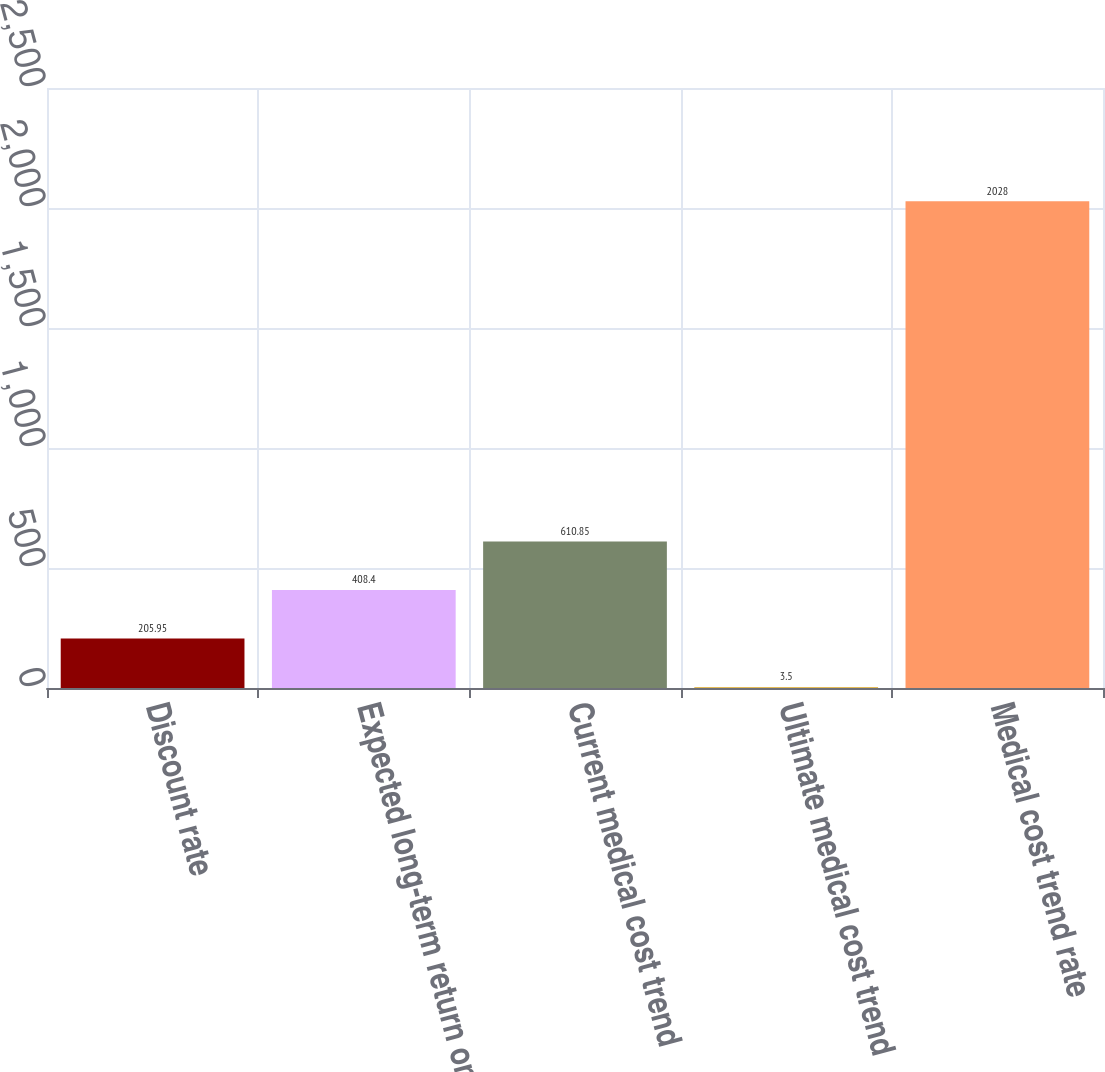<chart> <loc_0><loc_0><loc_500><loc_500><bar_chart><fcel>Discount rate<fcel>Expected long-term return on<fcel>Current medical cost trend<fcel>Ultimate medical cost trend<fcel>Medical cost trend rate<nl><fcel>205.95<fcel>408.4<fcel>610.85<fcel>3.5<fcel>2028<nl></chart> 